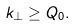<formula> <loc_0><loc_0><loc_500><loc_500>k _ { \perp } \geq Q _ { 0 } .</formula> 